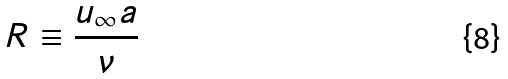Convert formula to latex. <formula><loc_0><loc_0><loc_500><loc_500>R \equiv \frac { u _ { \infty } a } { \nu }</formula> 